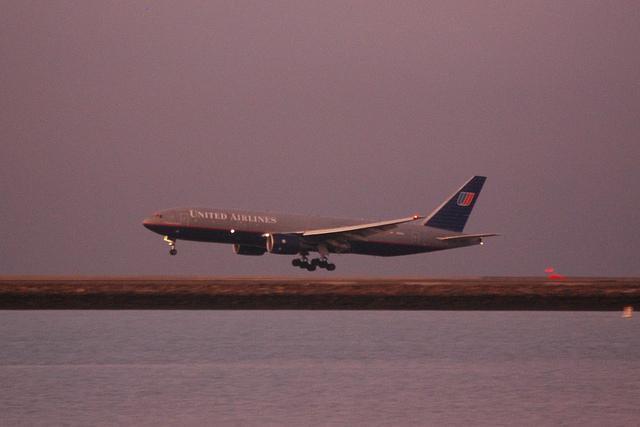How many planes do you see?
Give a very brief answer. 1. How many airplanes are there?
Give a very brief answer. 1. How many buoys are pictured?
Give a very brief answer. 1. 